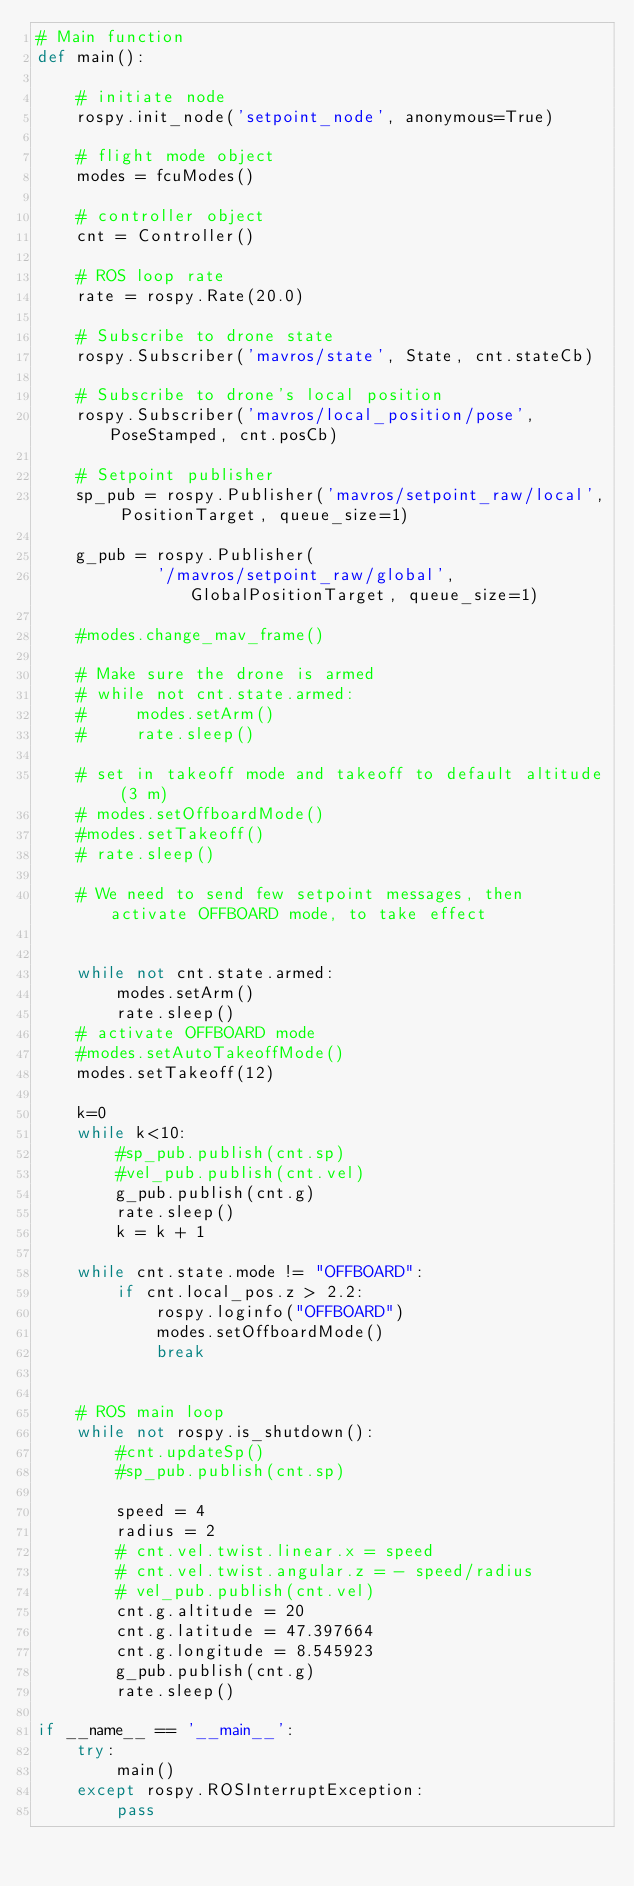<code> <loc_0><loc_0><loc_500><loc_500><_Python_># Main function
def main():

    # initiate node
    rospy.init_node('setpoint_node', anonymous=True)

    # flight mode object
    modes = fcuModes()

    # controller object
    cnt = Controller()

    # ROS loop rate
    rate = rospy.Rate(20.0)

    # Subscribe to drone state
    rospy.Subscriber('mavros/state', State, cnt.stateCb)

    # Subscribe to drone's local position
    rospy.Subscriber('mavros/local_position/pose', PoseStamped, cnt.posCb)

    # Setpoint publisher    
    sp_pub = rospy.Publisher('mavros/setpoint_raw/local', PositionTarget, queue_size=1)

    g_pub = rospy.Publisher(
            '/mavros/setpoint_raw/global', GlobalPositionTarget, queue_size=1)

    #modes.change_mav_frame()

    # Make sure the drone is armed
    # while not cnt.state.armed:
    #     modes.setArm()
    #     rate.sleep()

    # set in takeoff mode and takeoff to default altitude (3 m)
    # modes.setOffboardMode()
    #modes.setTakeoff()
    # rate.sleep()

    # We need to send few setpoint messages, then activate OFFBOARD mode, to take effect


    while not cnt.state.armed:
        modes.setArm()
        rate.sleep()
    # activate OFFBOARD mode
    #modes.setAutoTakeoffMode()
    modes.setTakeoff(12)

    k=0
    while k<10:
        #sp_pub.publish(cnt.sp)
        #vel_pub.publish(cnt.vel)
        g_pub.publish(cnt.g)
        rate.sleep()
        k = k + 1
    
    while cnt.state.mode != "OFFBOARD":
        if cnt.local_pos.z > 2.2:
            rospy.loginfo("OFFBOARD")
            modes.setOffboardMode()
            break


    # ROS main loop
    while not rospy.is_shutdown():
        #cnt.updateSp()
        #sp_pub.publish(cnt.sp)

        speed = 4
        radius = 2
        # cnt.vel.twist.linear.x = speed
        # cnt.vel.twist.angular.z = - speed/radius
        # vel_pub.publish(cnt.vel)
        cnt.g.altitude = 20
        cnt.g.latitude = 47.397664
        cnt.g.longitude = 8.545923
        g_pub.publish(cnt.g)
        rate.sleep()

if __name__ == '__main__':
    try:
        main()
    except rospy.ROSInterruptException:
        pass
</code> 